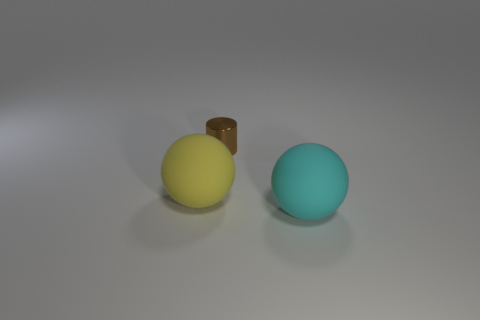Are there any other things that are the same size as the brown metallic object?
Provide a succinct answer. No. Is there anything else that is the same shape as the brown metallic object?
Give a very brief answer. No. Are there any metallic cylinders?
Your response must be concise. Yes. Is the tiny brown metal object the same shape as the yellow matte thing?
Your response must be concise. No. What number of small things are either purple objects or yellow balls?
Make the answer very short. 0. The small shiny thing is what color?
Your response must be concise. Brown. The object that is behind the big rubber sphere that is on the left side of the metallic cylinder is what shape?
Ensure brevity in your answer.  Cylinder. Are there any large cyan balls that have the same material as the small brown cylinder?
Make the answer very short. No. There is a object left of the cylinder; is it the same size as the cyan rubber thing?
Provide a succinct answer. Yes. What number of gray things are tiny objects or big metal cubes?
Offer a terse response. 0. 